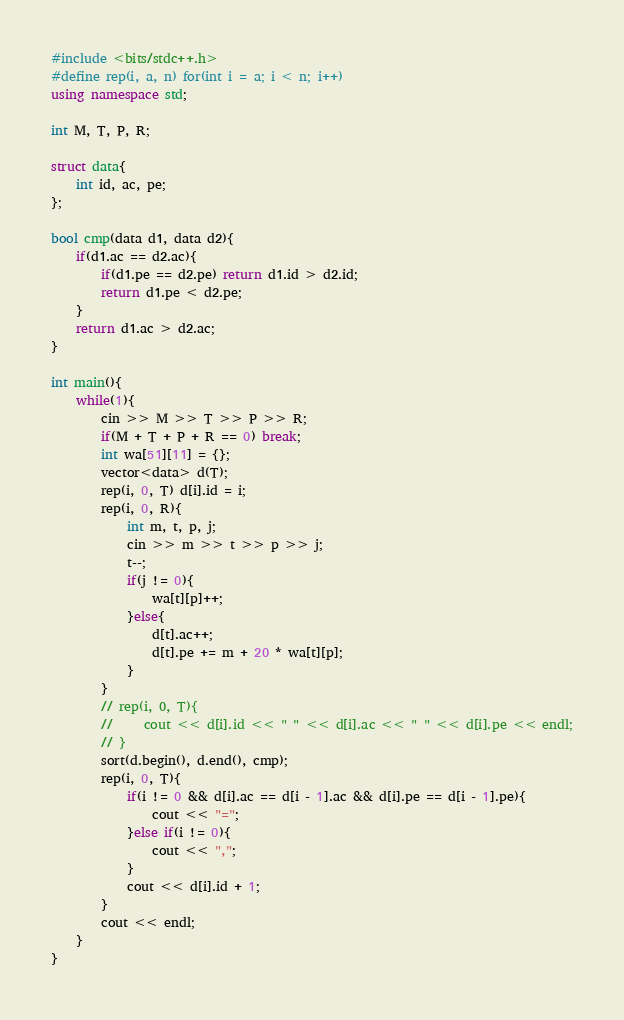Convert code to text. <code><loc_0><loc_0><loc_500><loc_500><_C++_>#include <bits/stdc++.h>
#define rep(i, a, n) for(int i = a; i < n; i++)
using namespace std;

int M, T, P, R;

struct data{
    int id, ac, pe;
};

bool cmp(data d1, data d2){
    if(d1.ac == d2.ac){
        if(d1.pe == d2.pe) return d1.id > d2.id;
        return d1.pe < d2.pe;
    }
    return d1.ac > d2.ac;
}

int main(){
    while(1){
        cin >> M >> T >> P >> R;
        if(M + T + P + R == 0) break;
        int wa[51][11] = {};
        vector<data> d(T);
        rep(i, 0, T) d[i].id = i;
        rep(i, 0, R){
            int m, t, p, j;
            cin >> m >> t >> p >> j;
            t--;
            if(j != 0){
                wa[t][p]++;
            }else{
                d[t].ac++;
                d[t].pe += m + 20 * wa[t][p];
            }
        }
        // rep(i, 0, T){
        //     cout << d[i].id << " " << d[i].ac << " " << d[i].pe << endl;
        // }
        sort(d.begin(), d.end(), cmp);        
        rep(i, 0, T){
            if(i != 0 && d[i].ac == d[i - 1].ac && d[i].pe == d[i - 1].pe){
                cout << "=";
            }else if(i != 0){
                cout << ",";
            }
            cout << d[i].id + 1;
        }
        cout << endl;
    }
}</code> 